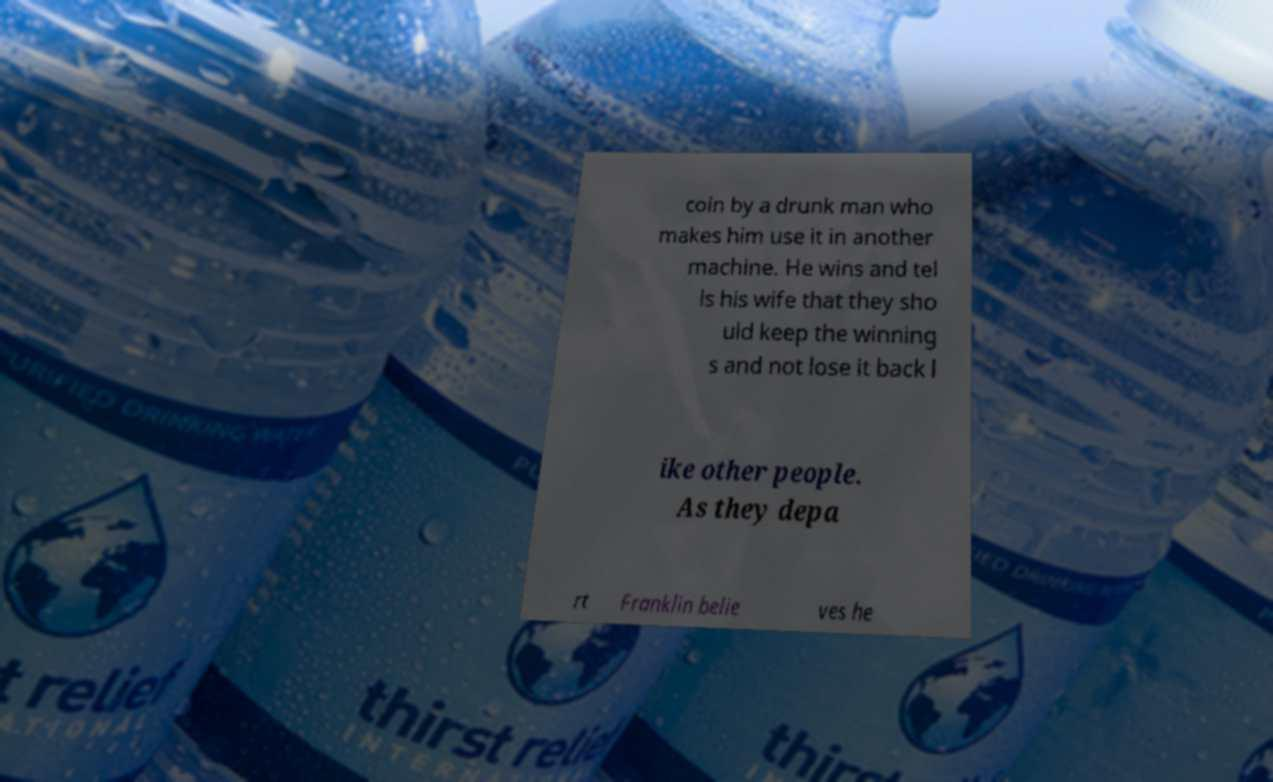I need the written content from this picture converted into text. Can you do that? coin by a drunk man who makes him use it in another machine. He wins and tel ls his wife that they sho uld keep the winning s and not lose it back l ike other people. As they depa rt Franklin belie ves he 